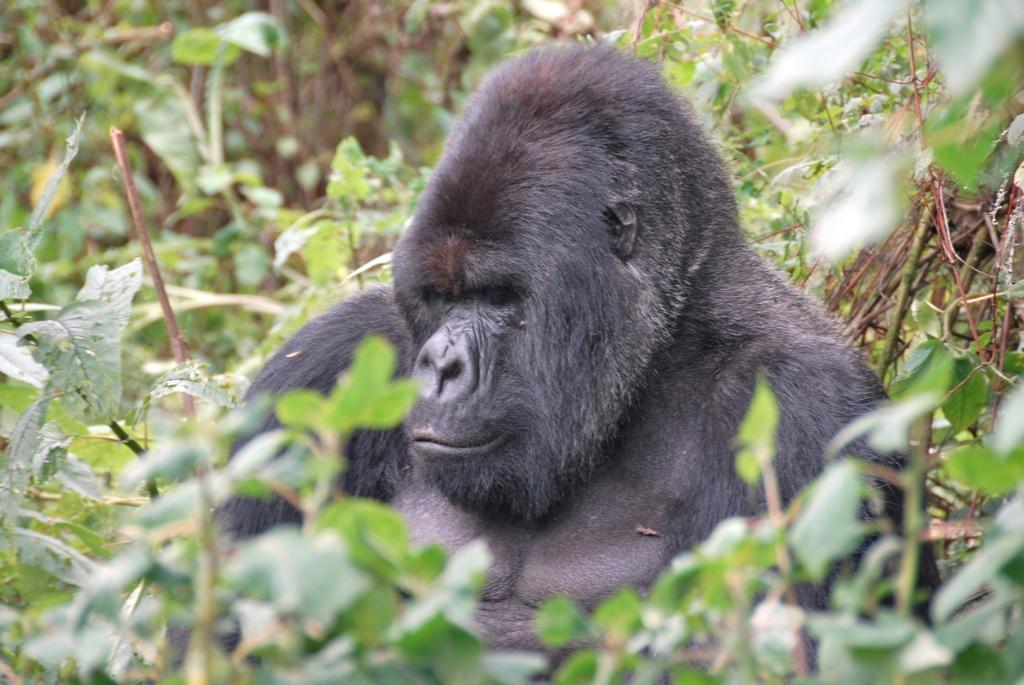Can you describe this image briefly? In this image in the center there is an animal which is black in colour and there are plants in the background. 